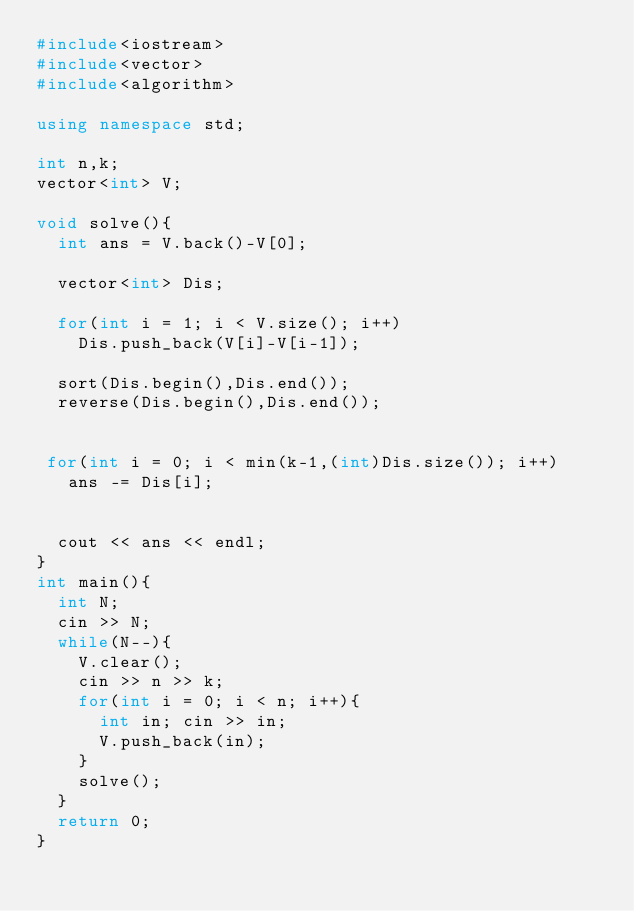<code> <loc_0><loc_0><loc_500><loc_500><_C++_>#include<iostream>
#include<vector>
#include<algorithm>

using namespace std;

int n,k;
vector<int> V;

void solve(){
  int ans = V.back()-V[0];
  
  vector<int> Dis;

  for(int i = 1; i < V.size(); i++)
    Dis.push_back(V[i]-V[i-1]);
    
  sort(Dis.begin(),Dis.end());
  reverse(Dis.begin(),Dis.end());

  
 for(int i = 0; i < min(k-1,(int)Dis.size()); i++)
   ans -= Dis[i];
 

  cout << ans << endl;
}
int main(){
  int N;
  cin >> N;
  while(N--){
    V.clear();
    cin >> n >> k;
    for(int i = 0; i < n; i++){
      int in; cin >> in;
      V.push_back(in);
    }
    solve();
  }
  return 0;
}</code> 